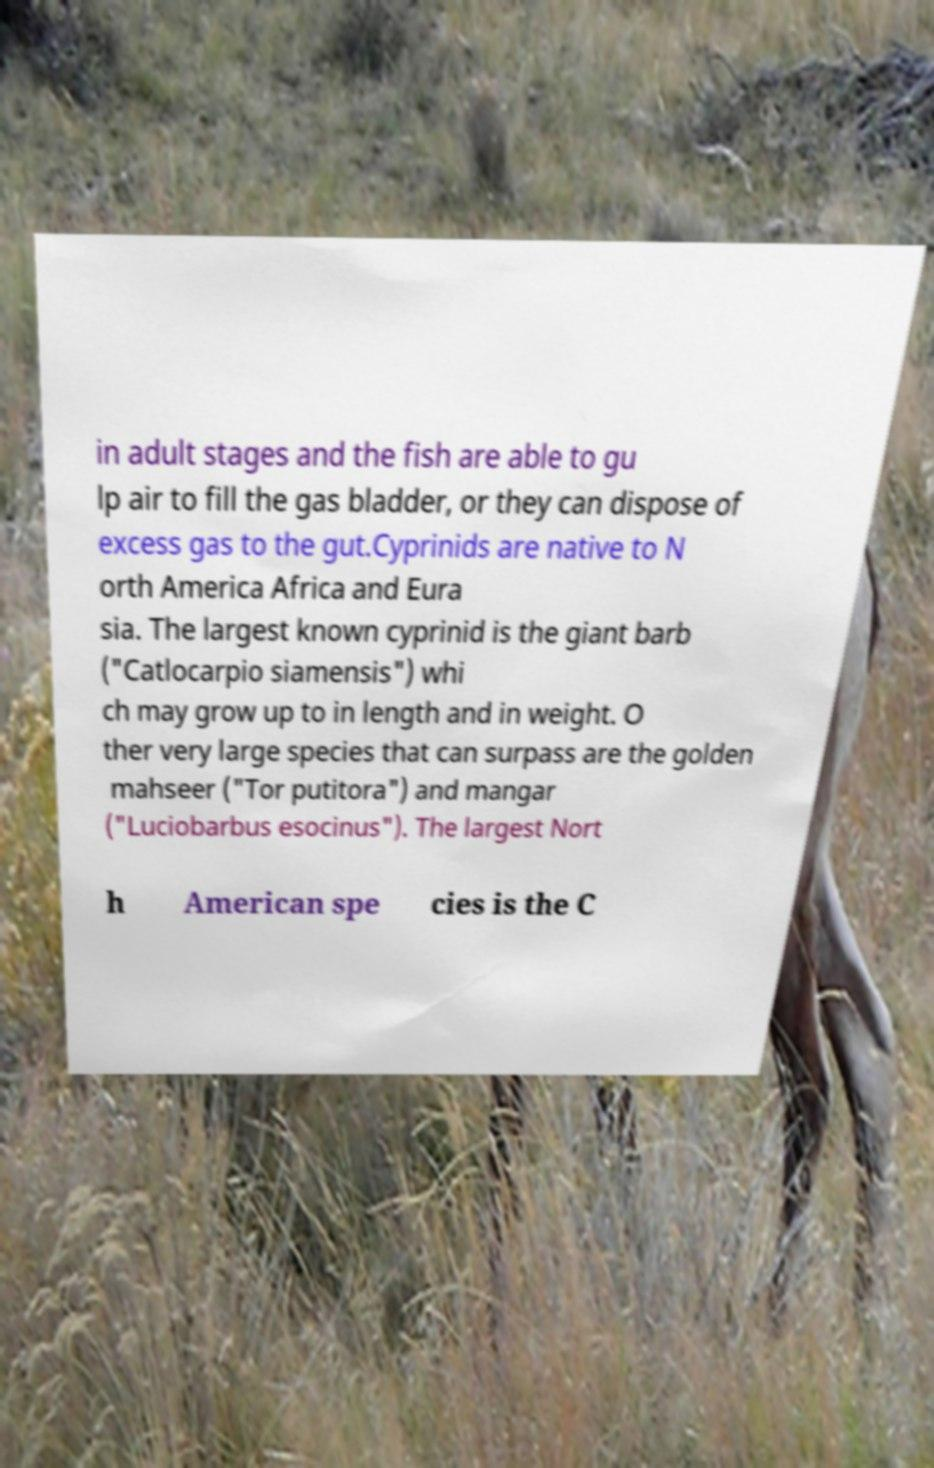There's text embedded in this image that I need extracted. Can you transcribe it verbatim? in adult stages and the fish are able to gu lp air to fill the gas bladder, or they can dispose of excess gas to the gut.Cyprinids are native to N orth America Africa and Eura sia. The largest known cyprinid is the giant barb ("Catlocarpio siamensis") whi ch may grow up to in length and in weight. O ther very large species that can surpass are the golden mahseer ("Tor putitora") and mangar ("Luciobarbus esocinus"). The largest Nort h American spe cies is the C 